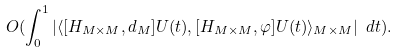Convert formula to latex. <formula><loc_0><loc_0><loc_500><loc_500>O ( \int _ { 0 } ^ { 1 } | \langle [ H _ { M \times M } , d _ { M } ] U ( t ) , [ H _ { M \times M } , \varphi ] U ( t ) \rangle _ { M \times M } | \ d t ) .</formula> 